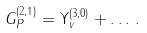Convert formula to latex. <formula><loc_0><loc_0><loc_500><loc_500>G ^ { ( 2 , 1 ) } _ { P } = \Upsilon ^ { ( 3 , 0 ) } _ { v } + \dots \, .</formula> 